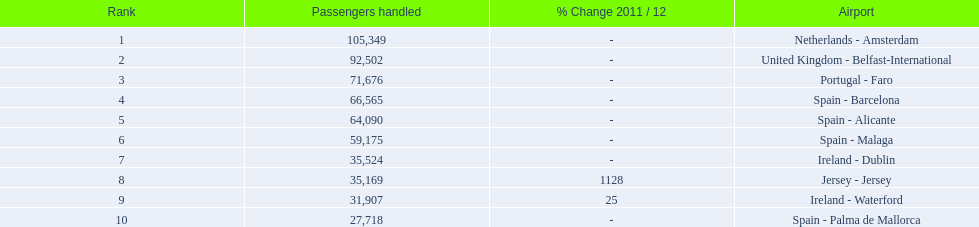What is the best rank? 1. What is the airport? Netherlands - Amsterdam. 